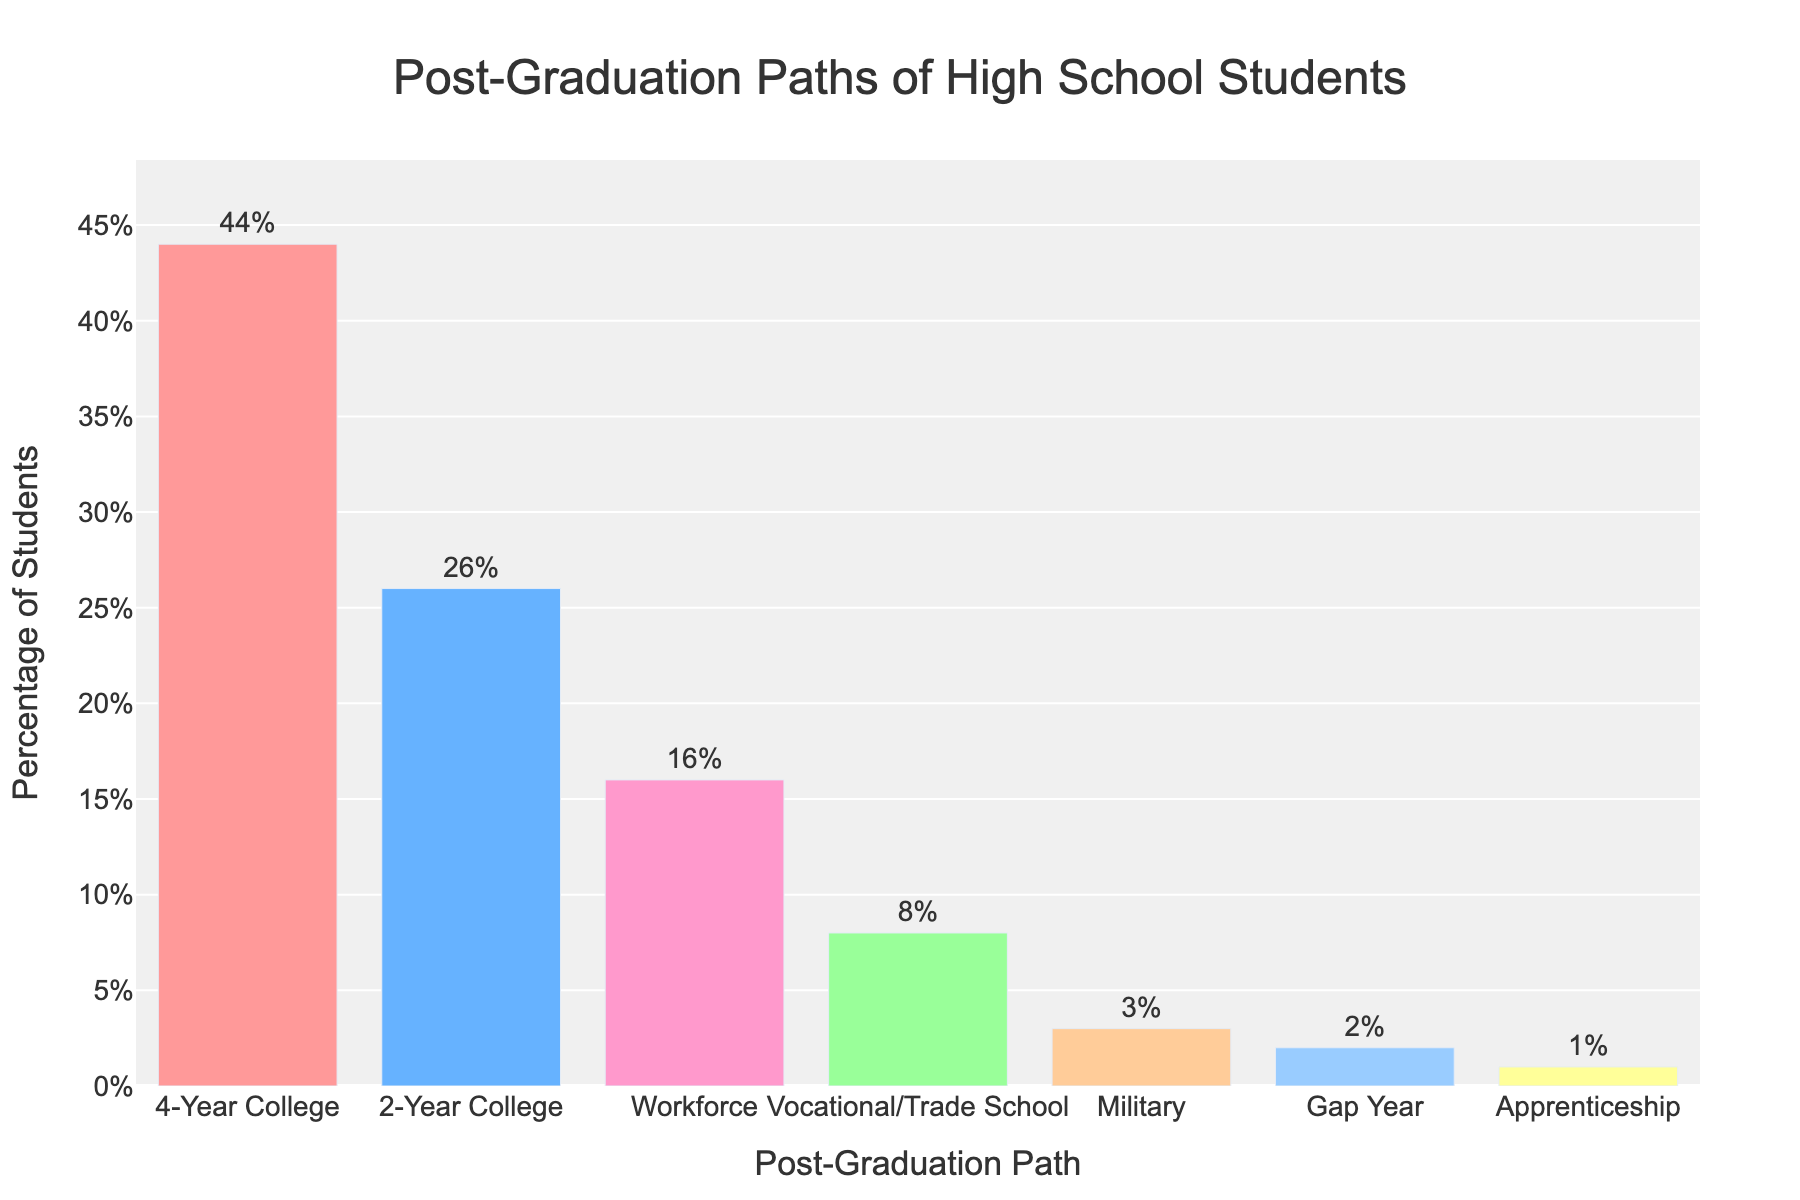Which post-graduation path has the highest percentage of students? The figure shows a bar representing the percentage of students for each post-graduation path. The tallest bar corresponds to the 4-Year College, which has the highest percentage.
Answer: 4-Year College What is the total percentage of students pursuing college education, combining both 4-Year College and 2-Year College paths? The percentage of students pursuing a 4-Year College is 44%, and for a 2-Year College, it is 26%. Summing these percentages gives 44% + 26% = 70%.
Answer: 70% Which post-graduation paths have less than 5% of students? The bars representing paths with less than 5% are those for Military (3%), Gap Year (2%), and Apprenticeship (1%).
Answer: Military, Gap Year, Apprenticeship How does the percentage of students going to vocational/trade school compare to those entering the workforce? The percentage of students going to vocational/trade school is 8%, while the percentage entering the workforce is 16%. Since 16% is greater than 8%, more students are entering the workforce.
Answer: More students enter the workforce What is the combined percentage of students going into the Military, taking a Gap Year, or starting an Apprenticeship? The percentage of students for each path is: Military (3%), Gap Year (2%), Apprenticeship (1%). Summing these gives 3% + 2% + 1% = 6%.
Answer: 6% Which post-graduation path has the smallest percentage of students, and what is that percentage? The shortest bar corresponds to Apprenticeship, which has a percentage of 1%.
Answer: Apprenticeship, 1% By how much does the percentage of students entering a 4-Year College exceed those entering the workforce? The percentage of students entering a 4-Year College is 44%, and those entering the workforce is 16%. The difference is 44% - 16% = 28%.
Answer: 28% Which post-graduation path has a higher percentage of students: Military or Gap Year? The bar for Military shows 3%, and for Gap Year, it is 2%. Since 3% is greater than 2%, more students choose the Military.
Answer: Military What percentage of students choose either Vocational/Trade School or Apprenticeship paths? The percentage of students going to Vocational/Trade School is 8%, and those starting an Apprenticeship is 1%. Summing these gives 8% + 1% = 9%.
Answer: 9% What is the median value of the percentages shown in the chart? The percentages from smallest to largest are 1%, 2%, 3%, 8%, 16%, 26%, and 44%. The middle value in this ordered list is 8%, which is the median.
Answer: 8% 